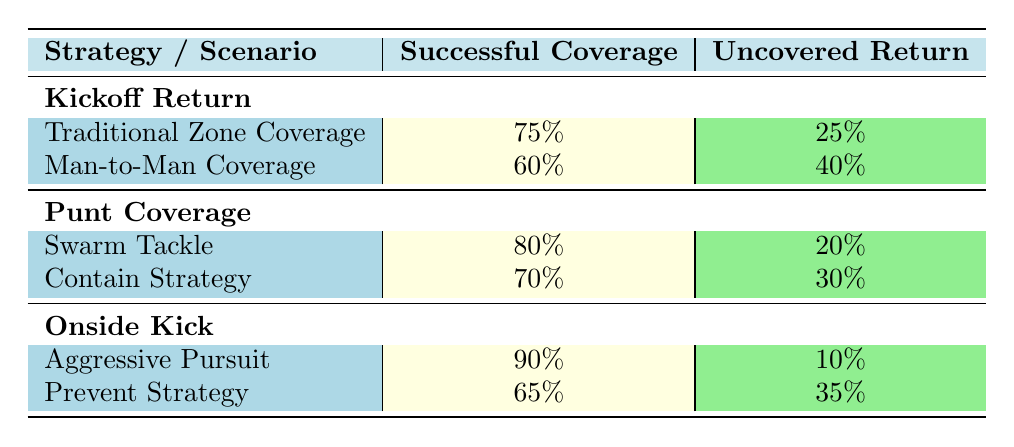What is the successful coverage percentage for the Traditional Zone Coverage strategy during a Kickoff Return? The table shows that the successful coverage for Traditional Zone Coverage is specified under the Kickoff Return scenario, which directly states that it is 75%.
Answer: 75% What is the uncovered return percentage for the Man-to-Man Coverage strategy during a Kickoff Return? The table indicates that under the Kickoff Return scenario, Man-to-Man Coverage has an uncovered return percentage of 40%.
Answer: 40% Which coverage strategy had the highest successful coverage during the Onside Kick scenario? By comparing the successful coverage percentages under the Onside Kick row, Aggressive Pursuit shows a successful coverage of 90%, which is the highest compared to the Prevent Strategy's 65%.
Answer: Aggressive Pursuit What is the average successful coverage percentage for all the strategies listed for Punt Coverage? The successful coverage percentages for Punt Coverage strategies are 80% for Swarm Tackle and 70% for Contain Strategy. Adding these values gives a total of 150%. Dividing by 2 (the number of strategies) gives an average of 75%.
Answer: 75% Is the Prevent Strategy under Onside Kick more effective than the Contain Strategy under Punt Coverage in terms of successful coverage? The Prevent Strategy has a successful coverage of 65%, while the Contain Strategy has a successful coverage of 70%. Therefore, the Prevent Strategy is less effective as it has a lower successful coverage percentage.
Answer: No Which coverage strategy results in the lowest uncovered return during Punk Coverage? Comparing the uncovered return percentages for Punk Coverage, Swarm Tackle has 20% uncovered while Contain Strategy has 30%. Since 20% is less than 30%, Swarm Tackle results in the lowest uncovered return.
Answer: Swarm Tackle What is the total uncovered return percentage across all strategies for the Onside Kick scenario? The uncovered return percentages for the Onside Kick strategies are 10% for Aggressive Pursuit and 35% for Prevent Strategy. Adding these, the total uncovered return is 10% + 35% = 45%.
Answer: 45% If we were to sort the successful coverage percentages from highest to lowest for the Kickoff Return, which strategy would be in second place? The successful coverage percentages for Kickoff Return are 75% for Traditional Zone Coverage and 60% for Man-to-Man Coverage. When sorted from highest to lowest, Traditional Zone Coverage is first and Man-to-Man Coverage is in second place.
Answer: Man-to-Man Coverage 